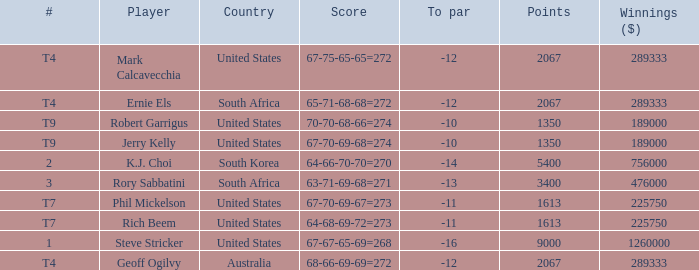Name the number of points for south korea 1.0. 